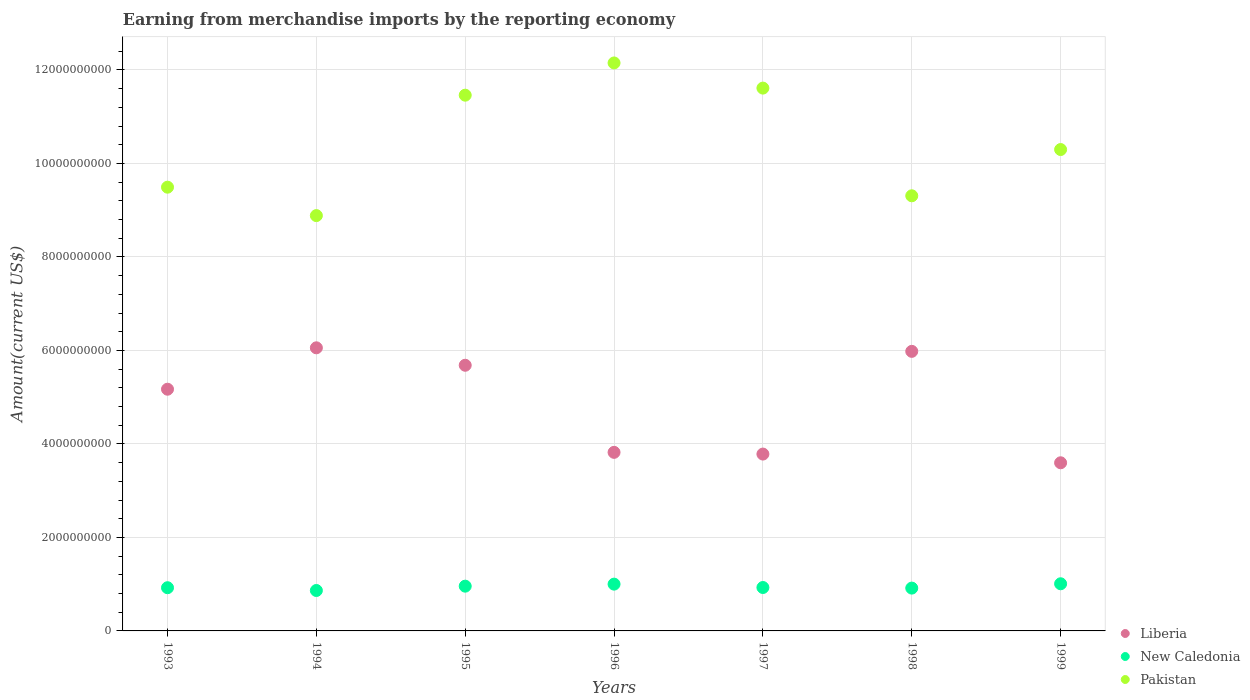How many different coloured dotlines are there?
Give a very brief answer. 3. Is the number of dotlines equal to the number of legend labels?
Provide a short and direct response. Yes. What is the amount earned from merchandise imports in New Caledonia in 1998?
Provide a succinct answer. 9.16e+08. Across all years, what is the maximum amount earned from merchandise imports in Pakistan?
Give a very brief answer. 1.21e+1. Across all years, what is the minimum amount earned from merchandise imports in New Caledonia?
Your response must be concise. 8.65e+08. What is the total amount earned from merchandise imports in Pakistan in the graph?
Offer a terse response. 7.32e+1. What is the difference between the amount earned from merchandise imports in Pakistan in 1993 and that in 1996?
Ensure brevity in your answer.  -2.66e+09. What is the difference between the amount earned from merchandise imports in Liberia in 1998 and the amount earned from merchandise imports in New Caledonia in 1995?
Provide a succinct answer. 5.02e+09. What is the average amount earned from merchandise imports in Pakistan per year?
Offer a very short reply. 1.05e+1. In the year 1995, what is the difference between the amount earned from merchandise imports in New Caledonia and amount earned from merchandise imports in Pakistan?
Provide a succinct answer. -1.05e+1. What is the ratio of the amount earned from merchandise imports in New Caledonia in 1994 to that in 1996?
Offer a very short reply. 0.86. Is the amount earned from merchandise imports in Liberia in 1994 less than that in 1999?
Ensure brevity in your answer.  No. What is the difference between the highest and the second highest amount earned from merchandise imports in Pakistan?
Give a very brief answer. 5.38e+08. What is the difference between the highest and the lowest amount earned from merchandise imports in Liberia?
Your answer should be compact. 2.46e+09. Is it the case that in every year, the sum of the amount earned from merchandise imports in Pakistan and amount earned from merchandise imports in New Caledonia  is greater than the amount earned from merchandise imports in Liberia?
Ensure brevity in your answer.  Yes. Does the amount earned from merchandise imports in New Caledonia monotonically increase over the years?
Give a very brief answer. No. Does the graph contain grids?
Your answer should be compact. Yes. Where does the legend appear in the graph?
Make the answer very short. Bottom right. How are the legend labels stacked?
Your answer should be very brief. Vertical. What is the title of the graph?
Provide a succinct answer. Earning from merchandise imports by the reporting economy. Does "San Marino" appear as one of the legend labels in the graph?
Your answer should be very brief. No. What is the label or title of the X-axis?
Offer a very short reply. Years. What is the label or title of the Y-axis?
Keep it short and to the point. Amount(current US$). What is the Amount(current US$) in Liberia in 1993?
Provide a succinct answer. 5.17e+09. What is the Amount(current US$) in New Caledonia in 1993?
Your answer should be very brief. 9.24e+08. What is the Amount(current US$) in Pakistan in 1993?
Offer a terse response. 9.49e+09. What is the Amount(current US$) of Liberia in 1994?
Your answer should be very brief. 6.06e+09. What is the Amount(current US$) of New Caledonia in 1994?
Make the answer very short. 8.65e+08. What is the Amount(current US$) in Pakistan in 1994?
Provide a succinct answer. 8.88e+09. What is the Amount(current US$) of Liberia in 1995?
Make the answer very short. 5.68e+09. What is the Amount(current US$) of New Caledonia in 1995?
Make the answer very short. 9.57e+08. What is the Amount(current US$) of Pakistan in 1995?
Make the answer very short. 1.15e+1. What is the Amount(current US$) in Liberia in 1996?
Offer a very short reply. 3.82e+09. What is the Amount(current US$) in New Caledonia in 1996?
Ensure brevity in your answer.  1.00e+09. What is the Amount(current US$) in Pakistan in 1996?
Provide a short and direct response. 1.21e+1. What is the Amount(current US$) in Liberia in 1997?
Your answer should be compact. 3.78e+09. What is the Amount(current US$) in New Caledonia in 1997?
Your response must be concise. 9.29e+08. What is the Amount(current US$) in Pakistan in 1997?
Your answer should be very brief. 1.16e+1. What is the Amount(current US$) of Liberia in 1998?
Your response must be concise. 5.98e+09. What is the Amount(current US$) of New Caledonia in 1998?
Your response must be concise. 9.16e+08. What is the Amount(current US$) of Pakistan in 1998?
Give a very brief answer. 9.31e+09. What is the Amount(current US$) in Liberia in 1999?
Your answer should be very brief. 3.60e+09. What is the Amount(current US$) in New Caledonia in 1999?
Your answer should be very brief. 1.01e+09. What is the Amount(current US$) of Pakistan in 1999?
Your response must be concise. 1.03e+1. Across all years, what is the maximum Amount(current US$) in Liberia?
Your answer should be compact. 6.06e+09. Across all years, what is the maximum Amount(current US$) in New Caledonia?
Offer a very short reply. 1.01e+09. Across all years, what is the maximum Amount(current US$) in Pakistan?
Offer a very short reply. 1.21e+1. Across all years, what is the minimum Amount(current US$) in Liberia?
Make the answer very short. 3.60e+09. Across all years, what is the minimum Amount(current US$) in New Caledonia?
Your answer should be compact. 8.65e+08. Across all years, what is the minimum Amount(current US$) in Pakistan?
Provide a succinct answer. 8.88e+09. What is the total Amount(current US$) of Liberia in the graph?
Ensure brevity in your answer.  3.41e+1. What is the total Amount(current US$) in New Caledonia in the graph?
Give a very brief answer. 6.60e+09. What is the total Amount(current US$) in Pakistan in the graph?
Offer a very short reply. 7.32e+1. What is the difference between the Amount(current US$) in Liberia in 1993 and that in 1994?
Provide a succinct answer. -8.86e+08. What is the difference between the Amount(current US$) of New Caledonia in 1993 and that in 1994?
Keep it short and to the point. 5.94e+07. What is the difference between the Amount(current US$) in Pakistan in 1993 and that in 1994?
Provide a short and direct response. 6.08e+08. What is the difference between the Amount(current US$) in Liberia in 1993 and that in 1995?
Give a very brief answer. -5.12e+08. What is the difference between the Amount(current US$) of New Caledonia in 1993 and that in 1995?
Provide a short and direct response. -3.32e+07. What is the difference between the Amount(current US$) of Pakistan in 1993 and that in 1995?
Keep it short and to the point. -1.97e+09. What is the difference between the Amount(current US$) in Liberia in 1993 and that in 1996?
Your answer should be compact. 1.35e+09. What is the difference between the Amount(current US$) of New Caledonia in 1993 and that in 1996?
Your answer should be compact. -7.66e+07. What is the difference between the Amount(current US$) of Pakistan in 1993 and that in 1996?
Your answer should be compact. -2.66e+09. What is the difference between the Amount(current US$) in Liberia in 1993 and that in 1997?
Provide a short and direct response. 1.39e+09. What is the difference between the Amount(current US$) of New Caledonia in 1993 and that in 1997?
Your answer should be very brief. -4.64e+06. What is the difference between the Amount(current US$) of Pakistan in 1993 and that in 1997?
Your answer should be very brief. -2.12e+09. What is the difference between the Amount(current US$) of Liberia in 1993 and that in 1998?
Offer a very short reply. -8.10e+08. What is the difference between the Amount(current US$) of New Caledonia in 1993 and that in 1998?
Your response must be concise. 8.29e+06. What is the difference between the Amount(current US$) of Pakistan in 1993 and that in 1998?
Your answer should be very brief. 1.84e+08. What is the difference between the Amount(current US$) in Liberia in 1993 and that in 1999?
Provide a succinct answer. 1.57e+09. What is the difference between the Amount(current US$) in New Caledonia in 1993 and that in 1999?
Your answer should be compact. -8.43e+07. What is the difference between the Amount(current US$) of Pakistan in 1993 and that in 1999?
Your answer should be compact. -8.05e+08. What is the difference between the Amount(current US$) in Liberia in 1994 and that in 1995?
Give a very brief answer. 3.73e+08. What is the difference between the Amount(current US$) in New Caledonia in 1994 and that in 1995?
Provide a succinct answer. -9.26e+07. What is the difference between the Amount(current US$) in Pakistan in 1994 and that in 1995?
Keep it short and to the point. -2.58e+09. What is the difference between the Amount(current US$) in Liberia in 1994 and that in 1996?
Provide a short and direct response. 2.24e+09. What is the difference between the Amount(current US$) in New Caledonia in 1994 and that in 1996?
Keep it short and to the point. -1.36e+08. What is the difference between the Amount(current US$) in Pakistan in 1994 and that in 1996?
Your response must be concise. -3.27e+09. What is the difference between the Amount(current US$) of Liberia in 1994 and that in 1997?
Your answer should be compact. 2.27e+09. What is the difference between the Amount(current US$) of New Caledonia in 1994 and that in 1997?
Make the answer very short. -6.40e+07. What is the difference between the Amount(current US$) of Pakistan in 1994 and that in 1997?
Your answer should be very brief. -2.73e+09. What is the difference between the Amount(current US$) of Liberia in 1994 and that in 1998?
Make the answer very short. 7.58e+07. What is the difference between the Amount(current US$) of New Caledonia in 1994 and that in 1998?
Provide a short and direct response. -5.11e+07. What is the difference between the Amount(current US$) in Pakistan in 1994 and that in 1998?
Offer a very short reply. -4.24e+08. What is the difference between the Amount(current US$) in Liberia in 1994 and that in 1999?
Make the answer very short. 2.46e+09. What is the difference between the Amount(current US$) in New Caledonia in 1994 and that in 1999?
Your response must be concise. -1.44e+08. What is the difference between the Amount(current US$) in Pakistan in 1994 and that in 1999?
Provide a succinct answer. -1.41e+09. What is the difference between the Amount(current US$) in Liberia in 1995 and that in 1996?
Provide a succinct answer. 1.86e+09. What is the difference between the Amount(current US$) of New Caledonia in 1995 and that in 1996?
Give a very brief answer. -4.34e+07. What is the difference between the Amount(current US$) in Pakistan in 1995 and that in 1996?
Offer a terse response. -6.89e+08. What is the difference between the Amount(current US$) of Liberia in 1995 and that in 1997?
Your answer should be compact. 1.90e+09. What is the difference between the Amount(current US$) in New Caledonia in 1995 and that in 1997?
Offer a very short reply. 2.85e+07. What is the difference between the Amount(current US$) of Pakistan in 1995 and that in 1997?
Offer a terse response. -1.51e+08. What is the difference between the Amount(current US$) of Liberia in 1995 and that in 1998?
Provide a short and direct response. -2.97e+08. What is the difference between the Amount(current US$) of New Caledonia in 1995 and that in 1998?
Make the answer very short. 4.15e+07. What is the difference between the Amount(current US$) in Pakistan in 1995 and that in 1998?
Provide a succinct answer. 2.15e+09. What is the difference between the Amount(current US$) of Liberia in 1995 and that in 1999?
Your response must be concise. 2.09e+09. What is the difference between the Amount(current US$) of New Caledonia in 1995 and that in 1999?
Your answer should be compact. -5.12e+07. What is the difference between the Amount(current US$) in Pakistan in 1995 and that in 1999?
Your answer should be compact. 1.16e+09. What is the difference between the Amount(current US$) in Liberia in 1996 and that in 1997?
Offer a very short reply. 3.68e+07. What is the difference between the Amount(current US$) of New Caledonia in 1996 and that in 1997?
Provide a succinct answer. 7.20e+07. What is the difference between the Amount(current US$) of Pakistan in 1996 and that in 1997?
Offer a very short reply. 5.38e+08. What is the difference between the Amount(current US$) in Liberia in 1996 and that in 1998?
Keep it short and to the point. -2.16e+09. What is the difference between the Amount(current US$) of New Caledonia in 1996 and that in 1998?
Offer a very short reply. 8.49e+07. What is the difference between the Amount(current US$) in Pakistan in 1996 and that in 1998?
Make the answer very short. 2.84e+09. What is the difference between the Amount(current US$) in Liberia in 1996 and that in 1999?
Your answer should be compact. 2.23e+08. What is the difference between the Amount(current US$) of New Caledonia in 1996 and that in 1999?
Keep it short and to the point. -7.71e+06. What is the difference between the Amount(current US$) of Pakistan in 1996 and that in 1999?
Provide a succinct answer. 1.85e+09. What is the difference between the Amount(current US$) of Liberia in 1997 and that in 1998?
Your response must be concise. -2.20e+09. What is the difference between the Amount(current US$) in New Caledonia in 1997 and that in 1998?
Give a very brief answer. 1.29e+07. What is the difference between the Amount(current US$) in Pakistan in 1997 and that in 1998?
Provide a short and direct response. 2.30e+09. What is the difference between the Amount(current US$) in Liberia in 1997 and that in 1999?
Offer a terse response. 1.86e+08. What is the difference between the Amount(current US$) in New Caledonia in 1997 and that in 1999?
Provide a succinct answer. -7.97e+07. What is the difference between the Amount(current US$) in Pakistan in 1997 and that in 1999?
Offer a terse response. 1.31e+09. What is the difference between the Amount(current US$) in Liberia in 1998 and that in 1999?
Offer a very short reply. 2.38e+09. What is the difference between the Amount(current US$) of New Caledonia in 1998 and that in 1999?
Offer a very short reply. -9.26e+07. What is the difference between the Amount(current US$) of Pakistan in 1998 and that in 1999?
Ensure brevity in your answer.  -9.89e+08. What is the difference between the Amount(current US$) in Liberia in 1993 and the Amount(current US$) in New Caledonia in 1994?
Your response must be concise. 4.31e+09. What is the difference between the Amount(current US$) of Liberia in 1993 and the Amount(current US$) of Pakistan in 1994?
Provide a short and direct response. -3.71e+09. What is the difference between the Amount(current US$) in New Caledonia in 1993 and the Amount(current US$) in Pakistan in 1994?
Provide a succinct answer. -7.96e+09. What is the difference between the Amount(current US$) in Liberia in 1993 and the Amount(current US$) in New Caledonia in 1995?
Offer a very short reply. 4.21e+09. What is the difference between the Amount(current US$) of Liberia in 1993 and the Amount(current US$) of Pakistan in 1995?
Keep it short and to the point. -6.29e+09. What is the difference between the Amount(current US$) of New Caledonia in 1993 and the Amount(current US$) of Pakistan in 1995?
Ensure brevity in your answer.  -1.05e+1. What is the difference between the Amount(current US$) in Liberia in 1993 and the Amount(current US$) in New Caledonia in 1996?
Provide a short and direct response. 4.17e+09. What is the difference between the Amount(current US$) in Liberia in 1993 and the Amount(current US$) in Pakistan in 1996?
Your answer should be compact. -6.98e+09. What is the difference between the Amount(current US$) of New Caledonia in 1993 and the Amount(current US$) of Pakistan in 1996?
Give a very brief answer. -1.12e+1. What is the difference between the Amount(current US$) in Liberia in 1993 and the Amount(current US$) in New Caledonia in 1997?
Offer a very short reply. 4.24e+09. What is the difference between the Amount(current US$) of Liberia in 1993 and the Amount(current US$) of Pakistan in 1997?
Ensure brevity in your answer.  -6.44e+09. What is the difference between the Amount(current US$) of New Caledonia in 1993 and the Amount(current US$) of Pakistan in 1997?
Provide a succinct answer. -1.07e+1. What is the difference between the Amount(current US$) of Liberia in 1993 and the Amount(current US$) of New Caledonia in 1998?
Make the answer very short. 4.25e+09. What is the difference between the Amount(current US$) of Liberia in 1993 and the Amount(current US$) of Pakistan in 1998?
Offer a terse response. -4.14e+09. What is the difference between the Amount(current US$) of New Caledonia in 1993 and the Amount(current US$) of Pakistan in 1998?
Your answer should be very brief. -8.38e+09. What is the difference between the Amount(current US$) in Liberia in 1993 and the Amount(current US$) in New Caledonia in 1999?
Give a very brief answer. 4.16e+09. What is the difference between the Amount(current US$) of Liberia in 1993 and the Amount(current US$) of Pakistan in 1999?
Keep it short and to the point. -5.13e+09. What is the difference between the Amount(current US$) of New Caledonia in 1993 and the Amount(current US$) of Pakistan in 1999?
Ensure brevity in your answer.  -9.37e+09. What is the difference between the Amount(current US$) of Liberia in 1994 and the Amount(current US$) of New Caledonia in 1995?
Keep it short and to the point. 5.10e+09. What is the difference between the Amount(current US$) of Liberia in 1994 and the Amount(current US$) of Pakistan in 1995?
Make the answer very short. -5.40e+09. What is the difference between the Amount(current US$) in New Caledonia in 1994 and the Amount(current US$) in Pakistan in 1995?
Ensure brevity in your answer.  -1.06e+1. What is the difference between the Amount(current US$) in Liberia in 1994 and the Amount(current US$) in New Caledonia in 1996?
Your response must be concise. 5.06e+09. What is the difference between the Amount(current US$) in Liberia in 1994 and the Amount(current US$) in Pakistan in 1996?
Your answer should be compact. -6.09e+09. What is the difference between the Amount(current US$) of New Caledonia in 1994 and the Amount(current US$) of Pakistan in 1996?
Offer a very short reply. -1.13e+1. What is the difference between the Amount(current US$) of Liberia in 1994 and the Amount(current US$) of New Caledonia in 1997?
Provide a succinct answer. 5.13e+09. What is the difference between the Amount(current US$) in Liberia in 1994 and the Amount(current US$) in Pakistan in 1997?
Provide a short and direct response. -5.56e+09. What is the difference between the Amount(current US$) in New Caledonia in 1994 and the Amount(current US$) in Pakistan in 1997?
Offer a terse response. -1.07e+1. What is the difference between the Amount(current US$) in Liberia in 1994 and the Amount(current US$) in New Caledonia in 1998?
Your answer should be compact. 5.14e+09. What is the difference between the Amount(current US$) in Liberia in 1994 and the Amount(current US$) in Pakistan in 1998?
Ensure brevity in your answer.  -3.25e+09. What is the difference between the Amount(current US$) in New Caledonia in 1994 and the Amount(current US$) in Pakistan in 1998?
Keep it short and to the point. -8.44e+09. What is the difference between the Amount(current US$) of Liberia in 1994 and the Amount(current US$) of New Caledonia in 1999?
Offer a terse response. 5.05e+09. What is the difference between the Amount(current US$) in Liberia in 1994 and the Amount(current US$) in Pakistan in 1999?
Your response must be concise. -4.24e+09. What is the difference between the Amount(current US$) in New Caledonia in 1994 and the Amount(current US$) in Pakistan in 1999?
Your response must be concise. -9.43e+09. What is the difference between the Amount(current US$) in Liberia in 1995 and the Amount(current US$) in New Caledonia in 1996?
Provide a short and direct response. 4.68e+09. What is the difference between the Amount(current US$) of Liberia in 1995 and the Amount(current US$) of Pakistan in 1996?
Your answer should be compact. -6.47e+09. What is the difference between the Amount(current US$) of New Caledonia in 1995 and the Amount(current US$) of Pakistan in 1996?
Ensure brevity in your answer.  -1.12e+1. What is the difference between the Amount(current US$) of Liberia in 1995 and the Amount(current US$) of New Caledonia in 1997?
Ensure brevity in your answer.  4.75e+09. What is the difference between the Amount(current US$) in Liberia in 1995 and the Amount(current US$) in Pakistan in 1997?
Offer a very short reply. -5.93e+09. What is the difference between the Amount(current US$) of New Caledonia in 1995 and the Amount(current US$) of Pakistan in 1997?
Provide a short and direct response. -1.07e+1. What is the difference between the Amount(current US$) in Liberia in 1995 and the Amount(current US$) in New Caledonia in 1998?
Your response must be concise. 4.77e+09. What is the difference between the Amount(current US$) in Liberia in 1995 and the Amount(current US$) in Pakistan in 1998?
Make the answer very short. -3.63e+09. What is the difference between the Amount(current US$) in New Caledonia in 1995 and the Amount(current US$) in Pakistan in 1998?
Your answer should be very brief. -8.35e+09. What is the difference between the Amount(current US$) of Liberia in 1995 and the Amount(current US$) of New Caledonia in 1999?
Make the answer very short. 4.67e+09. What is the difference between the Amount(current US$) in Liberia in 1995 and the Amount(current US$) in Pakistan in 1999?
Provide a succinct answer. -4.61e+09. What is the difference between the Amount(current US$) in New Caledonia in 1995 and the Amount(current US$) in Pakistan in 1999?
Ensure brevity in your answer.  -9.34e+09. What is the difference between the Amount(current US$) of Liberia in 1996 and the Amount(current US$) of New Caledonia in 1997?
Offer a terse response. 2.89e+09. What is the difference between the Amount(current US$) in Liberia in 1996 and the Amount(current US$) in Pakistan in 1997?
Offer a terse response. -7.79e+09. What is the difference between the Amount(current US$) of New Caledonia in 1996 and the Amount(current US$) of Pakistan in 1997?
Your answer should be very brief. -1.06e+1. What is the difference between the Amount(current US$) of Liberia in 1996 and the Amount(current US$) of New Caledonia in 1998?
Your response must be concise. 2.90e+09. What is the difference between the Amount(current US$) in Liberia in 1996 and the Amount(current US$) in Pakistan in 1998?
Keep it short and to the point. -5.49e+09. What is the difference between the Amount(current US$) of New Caledonia in 1996 and the Amount(current US$) of Pakistan in 1998?
Provide a short and direct response. -8.31e+09. What is the difference between the Amount(current US$) in Liberia in 1996 and the Amount(current US$) in New Caledonia in 1999?
Offer a terse response. 2.81e+09. What is the difference between the Amount(current US$) of Liberia in 1996 and the Amount(current US$) of Pakistan in 1999?
Make the answer very short. -6.48e+09. What is the difference between the Amount(current US$) of New Caledonia in 1996 and the Amount(current US$) of Pakistan in 1999?
Keep it short and to the point. -9.30e+09. What is the difference between the Amount(current US$) in Liberia in 1997 and the Amount(current US$) in New Caledonia in 1998?
Give a very brief answer. 2.87e+09. What is the difference between the Amount(current US$) of Liberia in 1997 and the Amount(current US$) of Pakistan in 1998?
Offer a very short reply. -5.53e+09. What is the difference between the Amount(current US$) of New Caledonia in 1997 and the Amount(current US$) of Pakistan in 1998?
Your answer should be compact. -8.38e+09. What is the difference between the Amount(current US$) of Liberia in 1997 and the Amount(current US$) of New Caledonia in 1999?
Make the answer very short. 2.77e+09. What is the difference between the Amount(current US$) of Liberia in 1997 and the Amount(current US$) of Pakistan in 1999?
Ensure brevity in your answer.  -6.51e+09. What is the difference between the Amount(current US$) in New Caledonia in 1997 and the Amount(current US$) in Pakistan in 1999?
Your answer should be compact. -9.37e+09. What is the difference between the Amount(current US$) in Liberia in 1998 and the Amount(current US$) in New Caledonia in 1999?
Give a very brief answer. 4.97e+09. What is the difference between the Amount(current US$) of Liberia in 1998 and the Amount(current US$) of Pakistan in 1999?
Offer a terse response. -4.32e+09. What is the difference between the Amount(current US$) of New Caledonia in 1998 and the Amount(current US$) of Pakistan in 1999?
Make the answer very short. -9.38e+09. What is the average Amount(current US$) of Liberia per year?
Give a very brief answer. 4.87e+09. What is the average Amount(current US$) of New Caledonia per year?
Ensure brevity in your answer.  9.43e+08. What is the average Amount(current US$) of Pakistan per year?
Keep it short and to the point. 1.05e+1. In the year 1993, what is the difference between the Amount(current US$) in Liberia and Amount(current US$) in New Caledonia?
Your answer should be compact. 4.25e+09. In the year 1993, what is the difference between the Amount(current US$) in Liberia and Amount(current US$) in Pakistan?
Your answer should be very brief. -4.32e+09. In the year 1993, what is the difference between the Amount(current US$) of New Caledonia and Amount(current US$) of Pakistan?
Offer a very short reply. -8.57e+09. In the year 1994, what is the difference between the Amount(current US$) in Liberia and Amount(current US$) in New Caledonia?
Provide a succinct answer. 5.19e+09. In the year 1994, what is the difference between the Amount(current US$) of Liberia and Amount(current US$) of Pakistan?
Provide a short and direct response. -2.83e+09. In the year 1994, what is the difference between the Amount(current US$) of New Caledonia and Amount(current US$) of Pakistan?
Make the answer very short. -8.02e+09. In the year 1995, what is the difference between the Amount(current US$) of Liberia and Amount(current US$) of New Caledonia?
Ensure brevity in your answer.  4.73e+09. In the year 1995, what is the difference between the Amount(current US$) in Liberia and Amount(current US$) in Pakistan?
Provide a succinct answer. -5.78e+09. In the year 1995, what is the difference between the Amount(current US$) in New Caledonia and Amount(current US$) in Pakistan?
Your answer should be compact. -1.05e+1. In the year 1996, what is the difference between the Amount(current US$) in Liberia and Amount(current US$) in New Caledonia?
Offer a very short reply. 2.82e+09. In the year 1996, what is the difference between the Amount(current US$) of Liberia and Amount(current US$) of Pakistan?
Your response must be concise. -8.33e+09. In the year 1996, what is the difference between the Amount(current US$) in New Caledonia and Amount(current US$) in Pakistan?
Ensure brevity in your answer.  -1.11e+1. In the year 1997, what is the difference between the Amount(current US$) in Liberia and Amount(current US$) in New Caledonia?
Offer a very short reply. 2.85e+09. In the year 1997, what is the difference between the Amount(current US$) of Liberia and Amount(current US$) of Pakistan?
Your answer should be compact. -7.83e+09. In the year 1997, what is the difference between the Amount(current US$) of New Caledonia and Amount(current US$) of Pakistan?
Your response must be concise. -1.07e+1. In the year 1998, what is the difference between the Amount(current US$) in Liberia and Amount(current US$) in New Caledonia?
Your answer should be compact. 5.06e+09. In the year 1998, what is the difference between the Amount(current US$) in Liberia and Amount(current US$) in Pakistan?
Offer a terse response. -3.33e+09. In the year 1998, what is the difference between the Amount(current US$) of New Caledonia and Amount(current US$) of Pakistan?
Your answer should be compact. -8.39e+09. In the year 1999, what is the difference between the Amount(current US$) in Liberia and Amount(current US$) in New Caledonia?
Offer a very short reply. 2.59e+09. In the year 1999, what is the difference between the Amount(current US$) in Liberia and Amount(current US$) in Pakistan?
Ensure brevity in your answer.  -6.70e+09. In the year 1999, what is the difference between the Amount(current US$) in New Caledonia and Amount(current US$) in Pakistan?
Your response must be concise. -9.29e+09. What is the ratio of the Amount(current US$) of Liberia in 1993 to that in 1994?
Your response must be concise. 0.85. What is the ratio of the Amount(current US$) of New Caledonia in 1993 to that in 1994?
Make the answer very short. 1.07. What is the ratio of the Amount(current US$) of Pakistan in 1993 to that in 1994?
Your response must be concise. 1.07. What is the ratio of the Amount(current US$) of Liberia in 1993 to that in 1995?
Your answer should be very brief. 0.91. What is the ratio of the Amount(current US$) in New Caledonia in 1993 to that in 1995?
Keep it short and to the point. 0.97. What is the ratio of the Amount(current US$) of Pakistan in 1993 to that in 1995?
Give a very brief answer. 0.83. What is the ratio of the Amount(current US$) of Liberia in 1993 to that in 1996?
Your answer should be compact. 1.35. What is the ratio of the Amount(current US$) of New Caledonia in 1993 to that in 1996?
Keep it short and to the point. 0.92. What is the ratio of the Amount(current US$) of Pakistan in 1993 to that in 1996?
Give a very brief answer. 0.78. What is the ratio of the Amount(current US$) of Liberia in 1993 to that in 1997?
Ensure brevity in your answer.  1.37. What is the ratio of the Amount(current US$) of Pakistan in 1993 to that in 1997?
Ensure brevity in your answer.  0.82. What is the ratio of the Amount(current US$) in Liberia in 1993 to that in 1998?
Keep it short and to the point. 0.86. What is the ratio of the Amount(current US$) in New Caledonia in 1993 to that in 1998?
Provide a succinct answer. 1.01. What is the ratio of the Amount(current US$) in Pakistan in 1993 to that in 1998?
Give a very brief answer. 1.02. What is the ratio of the Amount(current US$) of Liberia in 1993 to that in 1999?
Your answer should be very brief. 1.44. What is the ratio of the Amount(current US$) of New Caledonia in 1993 to that in 1999?
Offer a very short reply. 0.92. What is the ratio of the Amount(current US$) in Pakistan in 1993 to that in 1999?
Give a very brief answer. 0.92. What is the ratio of the Amount(current US$) in Liberia in 1994 to that in 1995?
Your response must be concise. 1.07. What is the ratio of the Amount(current US$) in New Caledonia in 1994 to that in 1995?
Keep it short and to the point. 0.9. What is the ratio of the Amount(current US$) of Pakistan in 1994 to that in 1995?
Give a very brief answer. 0.78. What is the ratio of the Amount(current US$) of Liberia in 1994 to that in 1996?
Offer a very short reply. 1.59. What is the ratio of the Amount(current US$) of New Caledonia in 1994 to that in 1996?
Offer a very short reply. 0.86. What is the ratio of the Amount(current US$) in Pakistan in 1994 to that in 1996?
Provide a succinct answer. 0.73. What is the ratio of the Amount(current US$) of Liberia in 1994 to that in 1997?
Your answer should be compact. 1.6. What is the ratio of the Amount(current US$) of New Caledonia in 1994 to that in 1997?
Provide a short and direct response. 0.93. What is the ratio of the Amount(current US$) of Pakistan in 1994 to that in 1997?
Make the answer very short. 0.77. What is the ratio of the Amount(current US$) of Liberia in 1994 to that in 1998?
Keep it short and to the point. 1.01. What is the ratio of the Amount(current US$) in New Caledonia in 1994 to that in 1998?
Provide a short and direct response. 0.94. What is the ratio of the Amount(current US$) of Pakistan in 1994 to that in 1998?
Ensure brevity in your answer.  0.95. What is the ratio of the Amount(current US$) of Liberia in 1994 to that in 1999?
Offer a terse response. 1.68. What is the ratio of the Amount(current US$) of New Caledonia in 1994 to that in 1999?
Offer a terse response. 0.86. What is the ratio of the Amount(current US$) of Pakistan in 1994 to that in 1999?
Your answer should be compact. 0.86. What is the ratio of the Amount(current US$) of Liberia in 1995 to that in 1996?
Provide a succinct answer. 1.49. What is the ratio of the Amount(current US$) of New Caledonia in 1995 to that in 1996?
Keep it short and to the point. 0.96. What is the ratio of the Amount(current US$) in Pakistan in 1995 to that in 1996?
Your answer should be compact. 0.94. What is the ratio of the Amount(current US$) of Liberia in 1995 to that in 1997?
Give a very brief answer. 1.5. What is the ratio of the Amount(current US$) in New Caledonia in 1995 to that in 1997?
Offer a very short reply. 1.03. What is the ratio of the Amount(current US$) in Liberia in 1995 to that in 1998?
Offer a very short reply. 0.95. What is the ratio of the Amount(current US$) of New Caledonia in 1995 to that in 1998?
Make the answer very short. 1.05. What is the ratio of the Amount(current US$) in Pakistan in 1995 to that in 1998?
Your answer should be compact. 1.23. What is the ratio of the Amount(current US$) of Liberia in 1995 to that in 1999?
Provide a short and direct response. 1.58. What is the ratio of the Amount(current US$) in New Caledonia in 1995 to that in 1999?
Your response must be concise. 0.95. What is the ratio of the Amount(current US$) in Pakistan in 1995 to that in 1999?
Ensure brevity in your answer.  1.11. What is the ratio of the Amount(current US$) of Liberia in 1996 to that in 1997?
Provide a short and direct response. 1.01. What is the ratio of the Amount(current US$) of New Caledonia in 1996 to that in 1997?
Provide a succinct answer. 1.08. What is the ratio of the Amount(current US$) of Pakistan in 1996 to that in 1997?
Give a very brief answer. 1.05. What is the ratio of the Amount(current US$) in Liberia in 1996 to that in 1998?
Ensure brevity in your answer.  0.64. What is the ratio of the Amount(current US$) in New Caledonia in 1996 to that in 1998?
Provide a short and direct response. 1.09. What is the ratio of the Amount(current US$) of Pakistan in 1996 to that in 1998?
Make the answer very short. 1.31. What is the ratio of the Amount(current US$) of Liberia in 1996 to that in 1999?
Ensure brevity in your answer.  1.06. What is the ratio of the Amount(current US$) in Pakistan in 1996 to that in 1999?
Give a very brief answer. 1.18. What is the ratio of the Amount(current US$) in Liberia in 1997 to that in 1998?
Your response must be concise. 0.63. What is the ratio of the Amount(current US$) of New Caledonia in 1997 to that in 1998?
Your answer should be compact. 1.01. What is the ratio of the Amount(current US$) in Pakistan in 1997 to that in 1998?
Your answer should be very brief. 1.25. What is the ratio of the Amount(current US$) in Liberia in 1997 to that in 1999?
Make the answer very short. 1.05. What is the ratio of the Amount(current US$) of New Caledonia in 1997 to that in 1999?
Provide a succinct answer. 0.92. What is the ratio of the Amount(current US$) in Pakistan in 1997 to that in 1999?
Offer a terse response. 1.13. What is the ratio of the Amount(current US$) of Liberia in 1998 to that in 1999?
Offer a very short reply. 1.66. What is the ratio of the Amount(current US$) of New Caledonia in 1998 to that in 1999?
Offer a terse response. 0.91. What is the ratio of the Amount(current US$) of Pakistan in 1998 to that in 1999?
Give a very brief answer. 0.9. What is the difference between the highest and the second highest Amount(current US$) in Liberia?
Provide a short and direct response. 7.58e+07. What is the difference between the highest and the second highest Amount(current US$) in New Caledonia?
Keep it short and to the point. 7.71e+06. What is the difference between the highest and the second highest Amount(current US$) in Pakistan?
Offer a very short reply. 5.38e+08. What is the difference between the highest and the lowest Amount(current US$) of Liberia?
Keep it short and to the point. 2.46e+09. What is the difference between the highest and the lowest Amount(current US$) of New Caledonia?
Offer a terse response. 1.44e+08. What is the difference between the highest and the lowest Amount(current US$) in Pakistan?
Ensure brevity in your answer.  3.27e+09. 